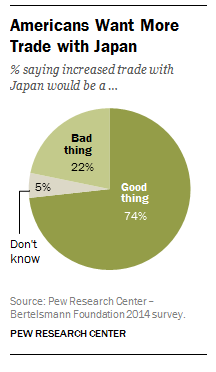Mention a couple of crucial points in this snapshot. The product of the two smallest segments in the number 110 is [object of interest]. The color of the Don't Know segment is gray. 